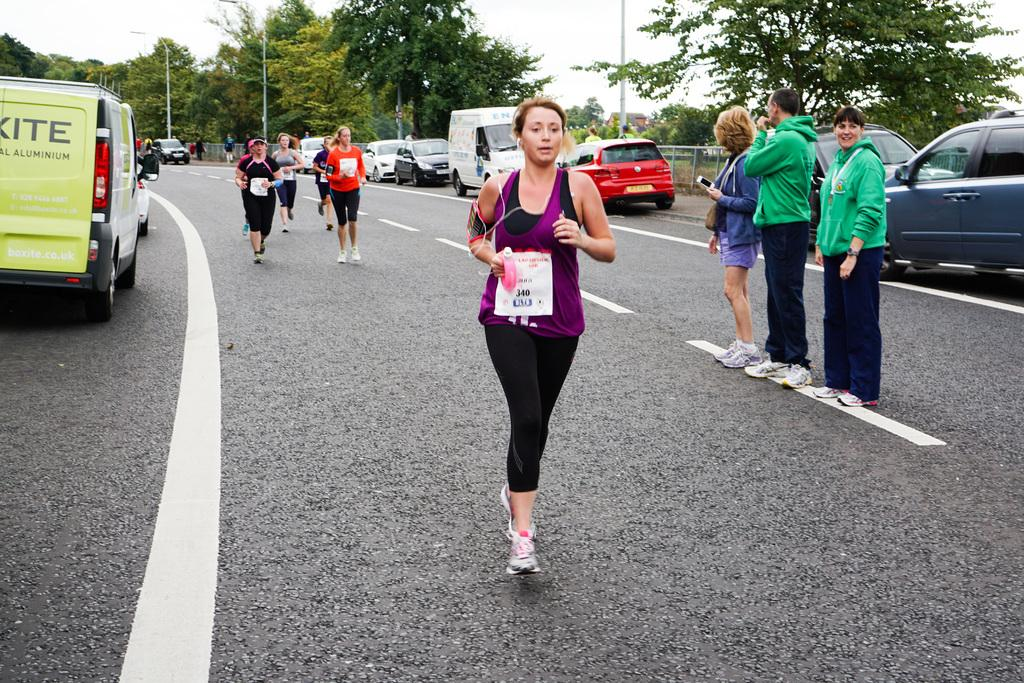Provide a one-sentence caption for the provided image. a lady that has 340 written on a white paper. 